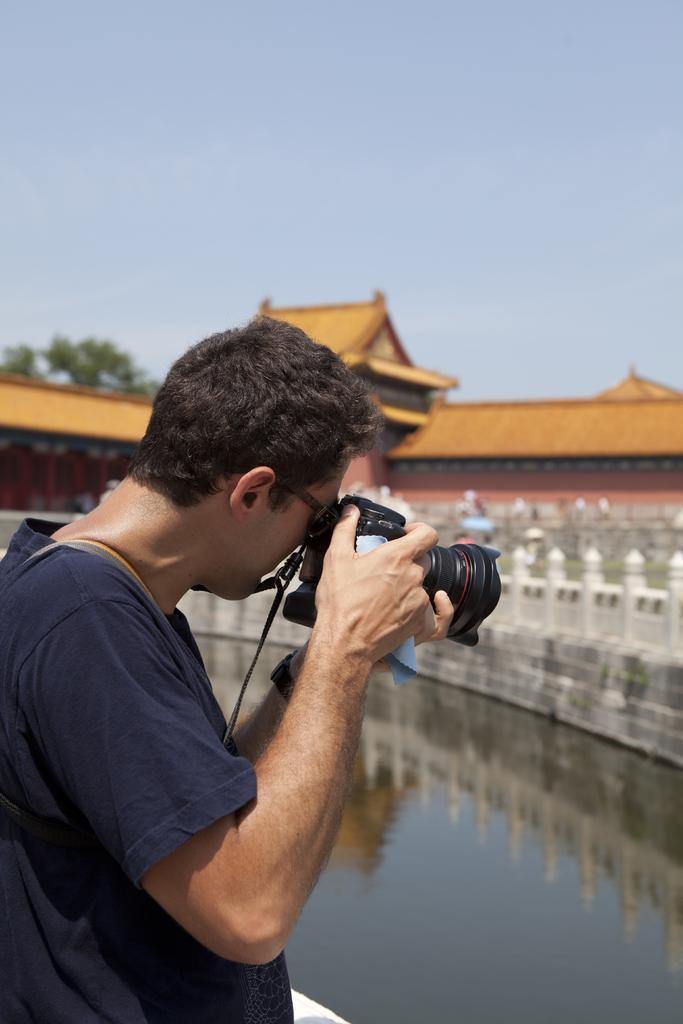In one or two sentences, can you explain what this image depicts? A person is taking picture. In the background there is a building,water,tree and sky. 